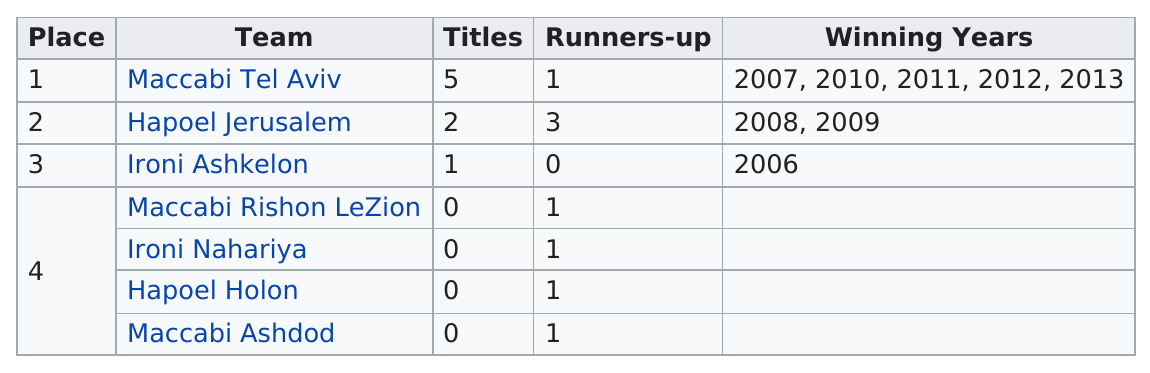Point out several critical features in this image. The team "Ironi Ashkelon" was the first to win among all the teams listed. Team Maccabi Tel Aviv won more titles than every other team combined by 2. In the years 2008 and 2009, Hapoel Jerusalem emerged as the winning team. Hapoel Jerusalem is the next team to Maccabi Tel Aviv. Eight runners-up titles have been awarded in total. 